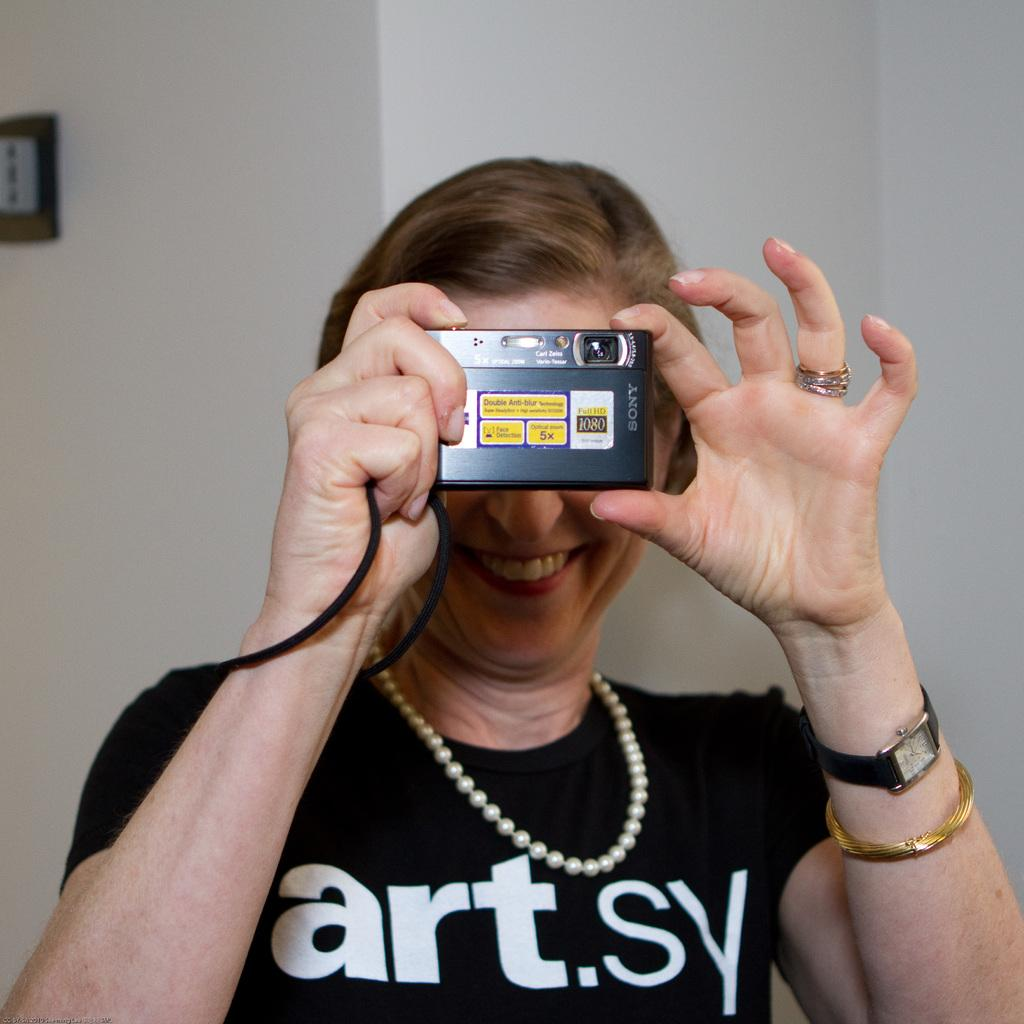Who is present in the image? There is a woman in the image. What is the woman holding in the image? The woman is holding a camera. What can be seen on the wall in the image? There is a frame on a wall in the image. How many snakes are visible in the image? There are no snakes present in the image. What type of vein is visible in the woman's arm in the image? There is no visible vein in the woman's arm in the image. 